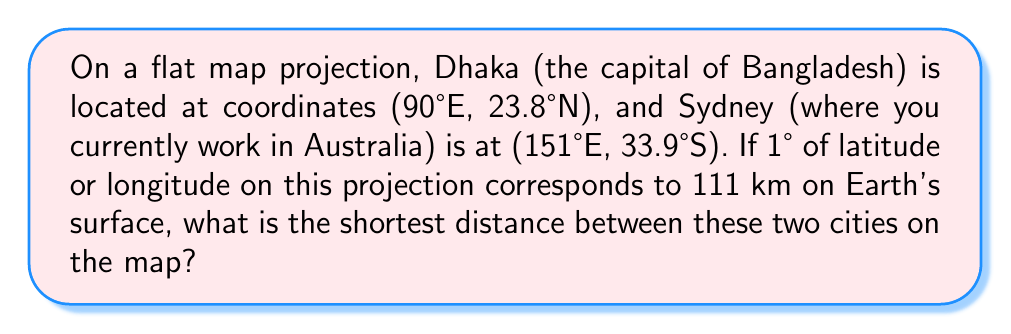Can you solve this math problem? To solve this problem, we'll use the following steps:

1) First, we need to calculate the difference in latitude and longitude between the two cities:

   Longitude difference: $151° - 90° = 61°$
   Latitude difference: $23.8° - (-33.9°) = 57.7°$ (note that S is negative)

2) Now, we can treat this as a right-angled triangle on the flat map, where:
   - The base is the longitude difference
   - The height is the latitude difference
   - The hypotenuse is the shortest path between the cities

3) We can use the Pythagorean theorem to calculate the length of the hypotenuse:

   $$c = \sqrt{a^2 + b^2}$$

   Where $c$ is the hypotenuse, $a$ is the base, and $b$ is the height.

4) First, we need to convert the degree differences to kilometers:

   Longitude difference in km: $61° \times 111 \text{ km/°} = 6771 \text{ km}$
   Latitude difference in km: $57.7° \times 111 \text{ km/°} = 6404.7 \text{ km}$

5) Now we can apply the Pythagorean theorem:

   $$c = \sqrt{6771^2 + 6404.7^2}$$

6) Calculating this:

   $$c = \sqrt{45846441 + 41020160.09} = \sqrt{86866601.09} \approx 9318.61 \text{ km}$$

Therefore, the shortest distance between Dhaka and Sydney on this flat map projection is approximately 9318.61 km.
Answer: 9318.61 km 